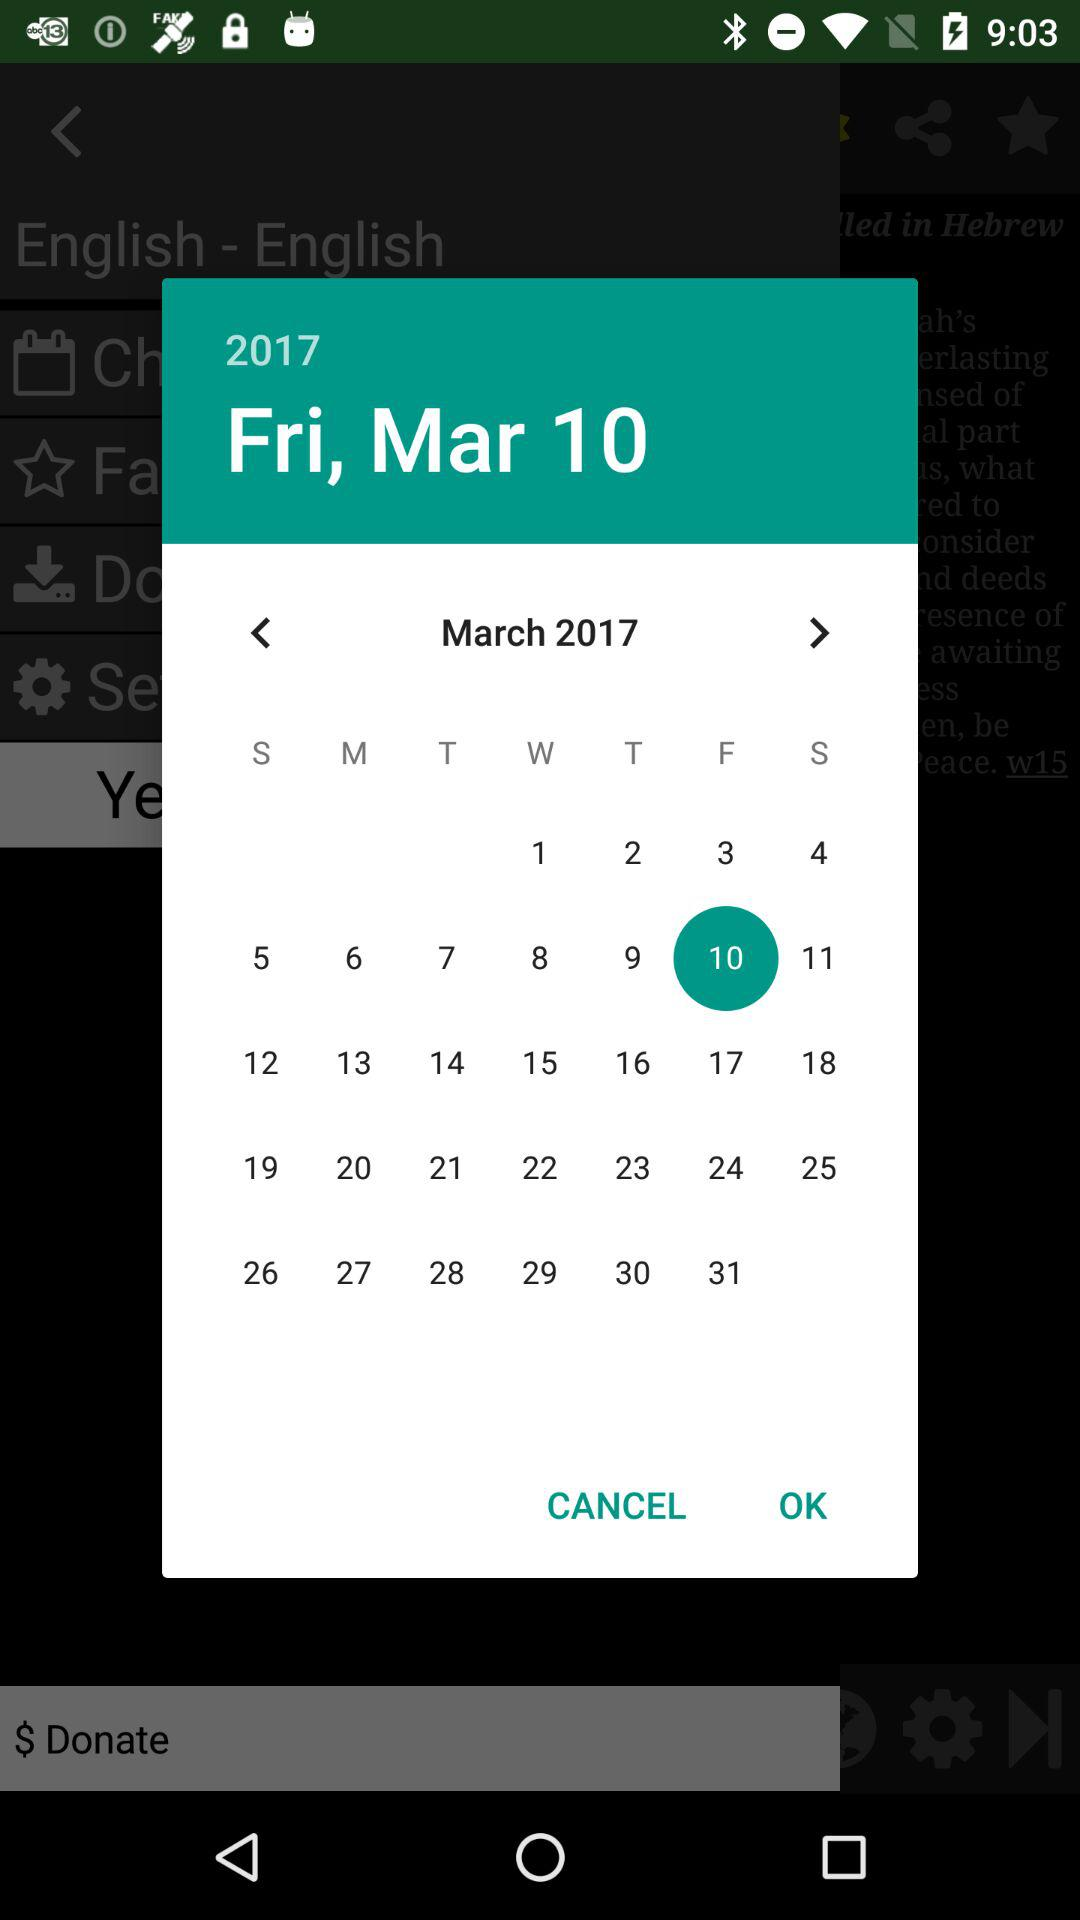Which day is March 1, 2017? The day is Wednesday. 